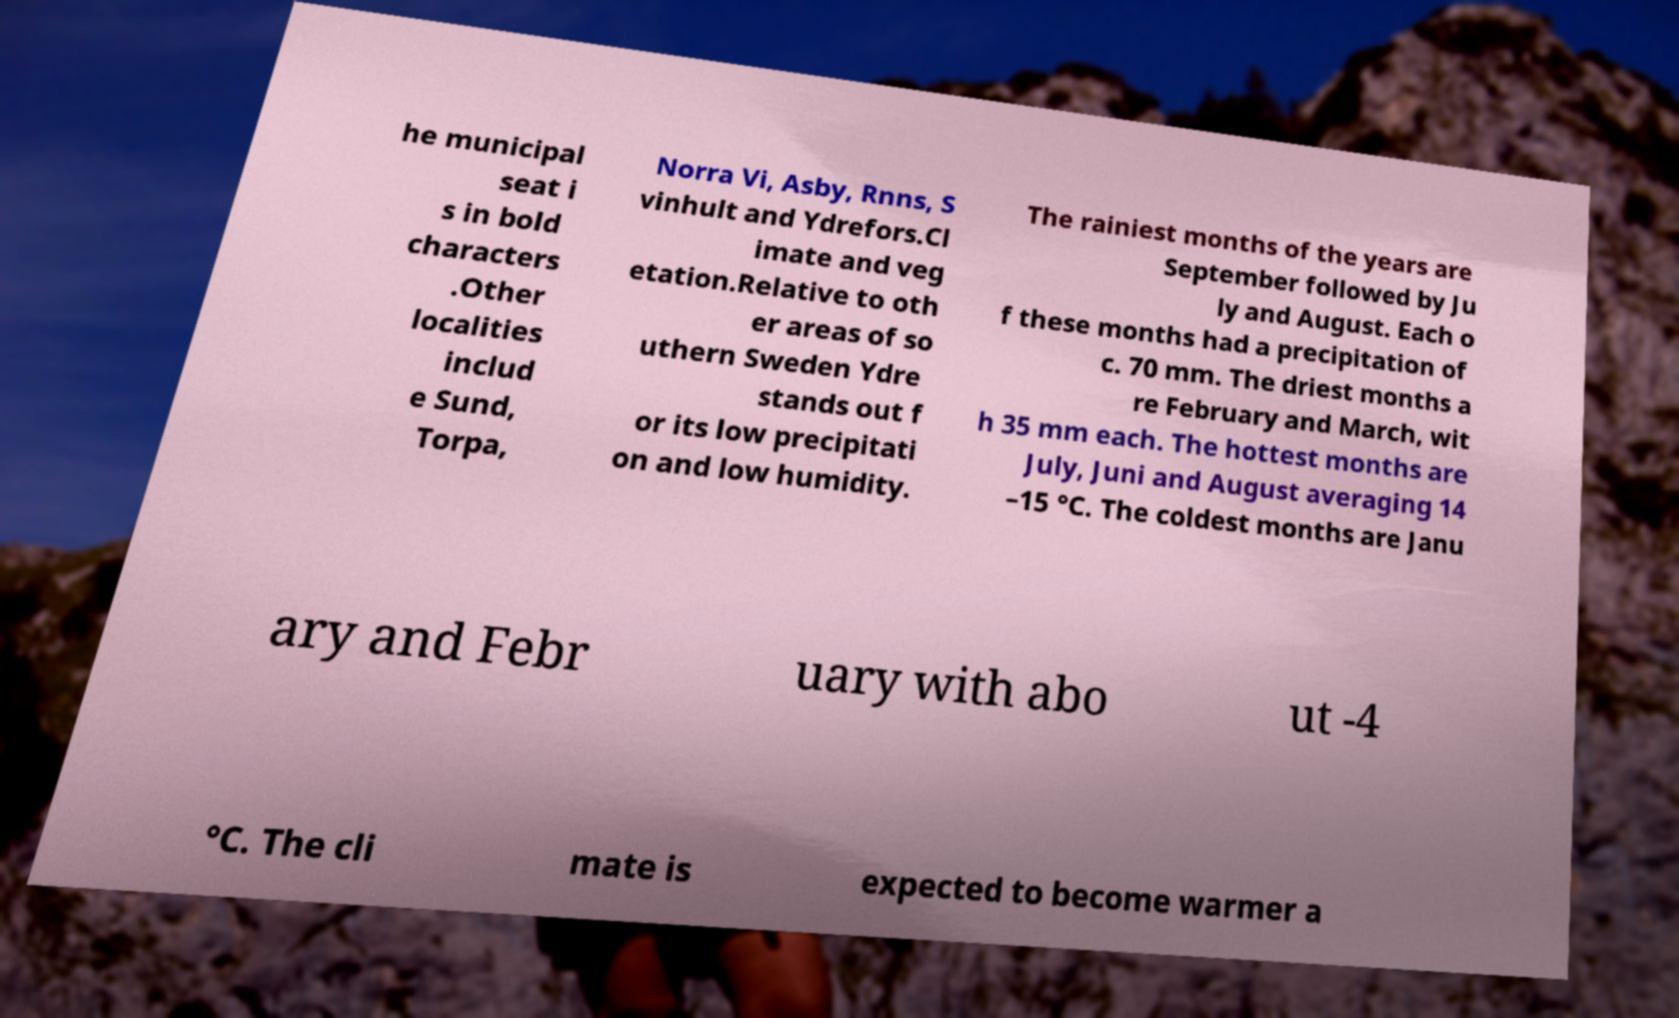There's text embedded in this image that I need extracted. Can you transcribe it verbatim? he municipal seat i s in bold characters .Other localities includ e Sund, Torpa, Norra Vi, Asby, Rnns, S vinhult and Ydrefors.Cl imate and veg etation.Relative to oth er areas of so uthern Sweden Ydre stands out f or its low precipitati on and low humidity. The rainiest months of the years are September followed by Ju ly and August. Each o f these months had a precipitation of c. 70 mm. The driest months a re February and March, wit h 35 mm each. The hottest months are July, Juni and August averaging 14 –15 °C. The coldest months are Janu ary and Febr uary with abo ut -4 °C. The cli mate is expected to become warmer a 